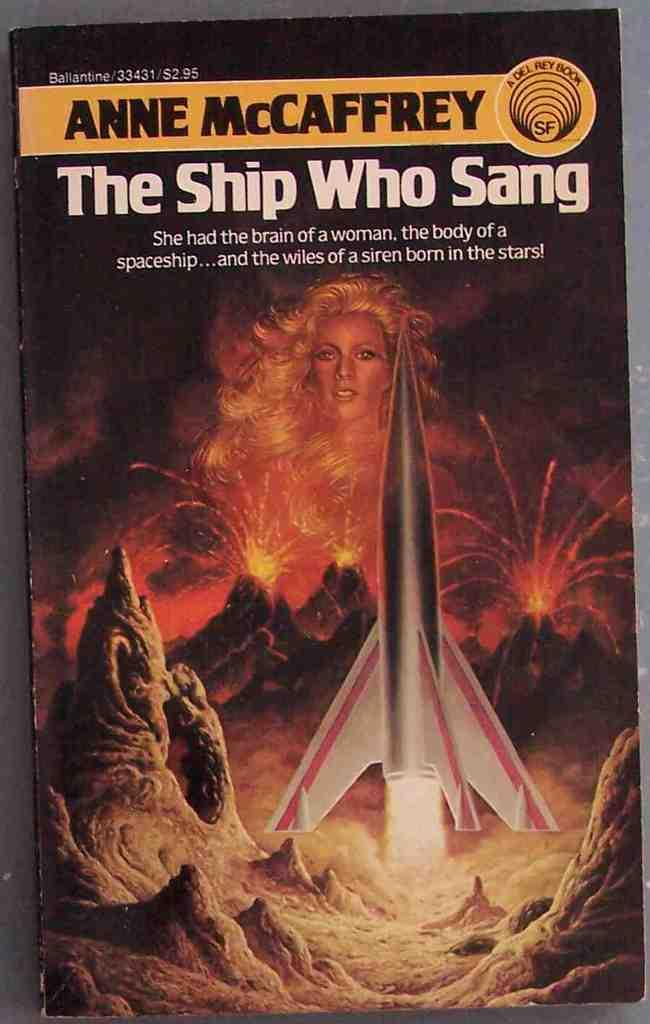<image>
Create a compact narrative representing the image presented. A book by Anne McCaffrey titled The Ship Who Sang. 